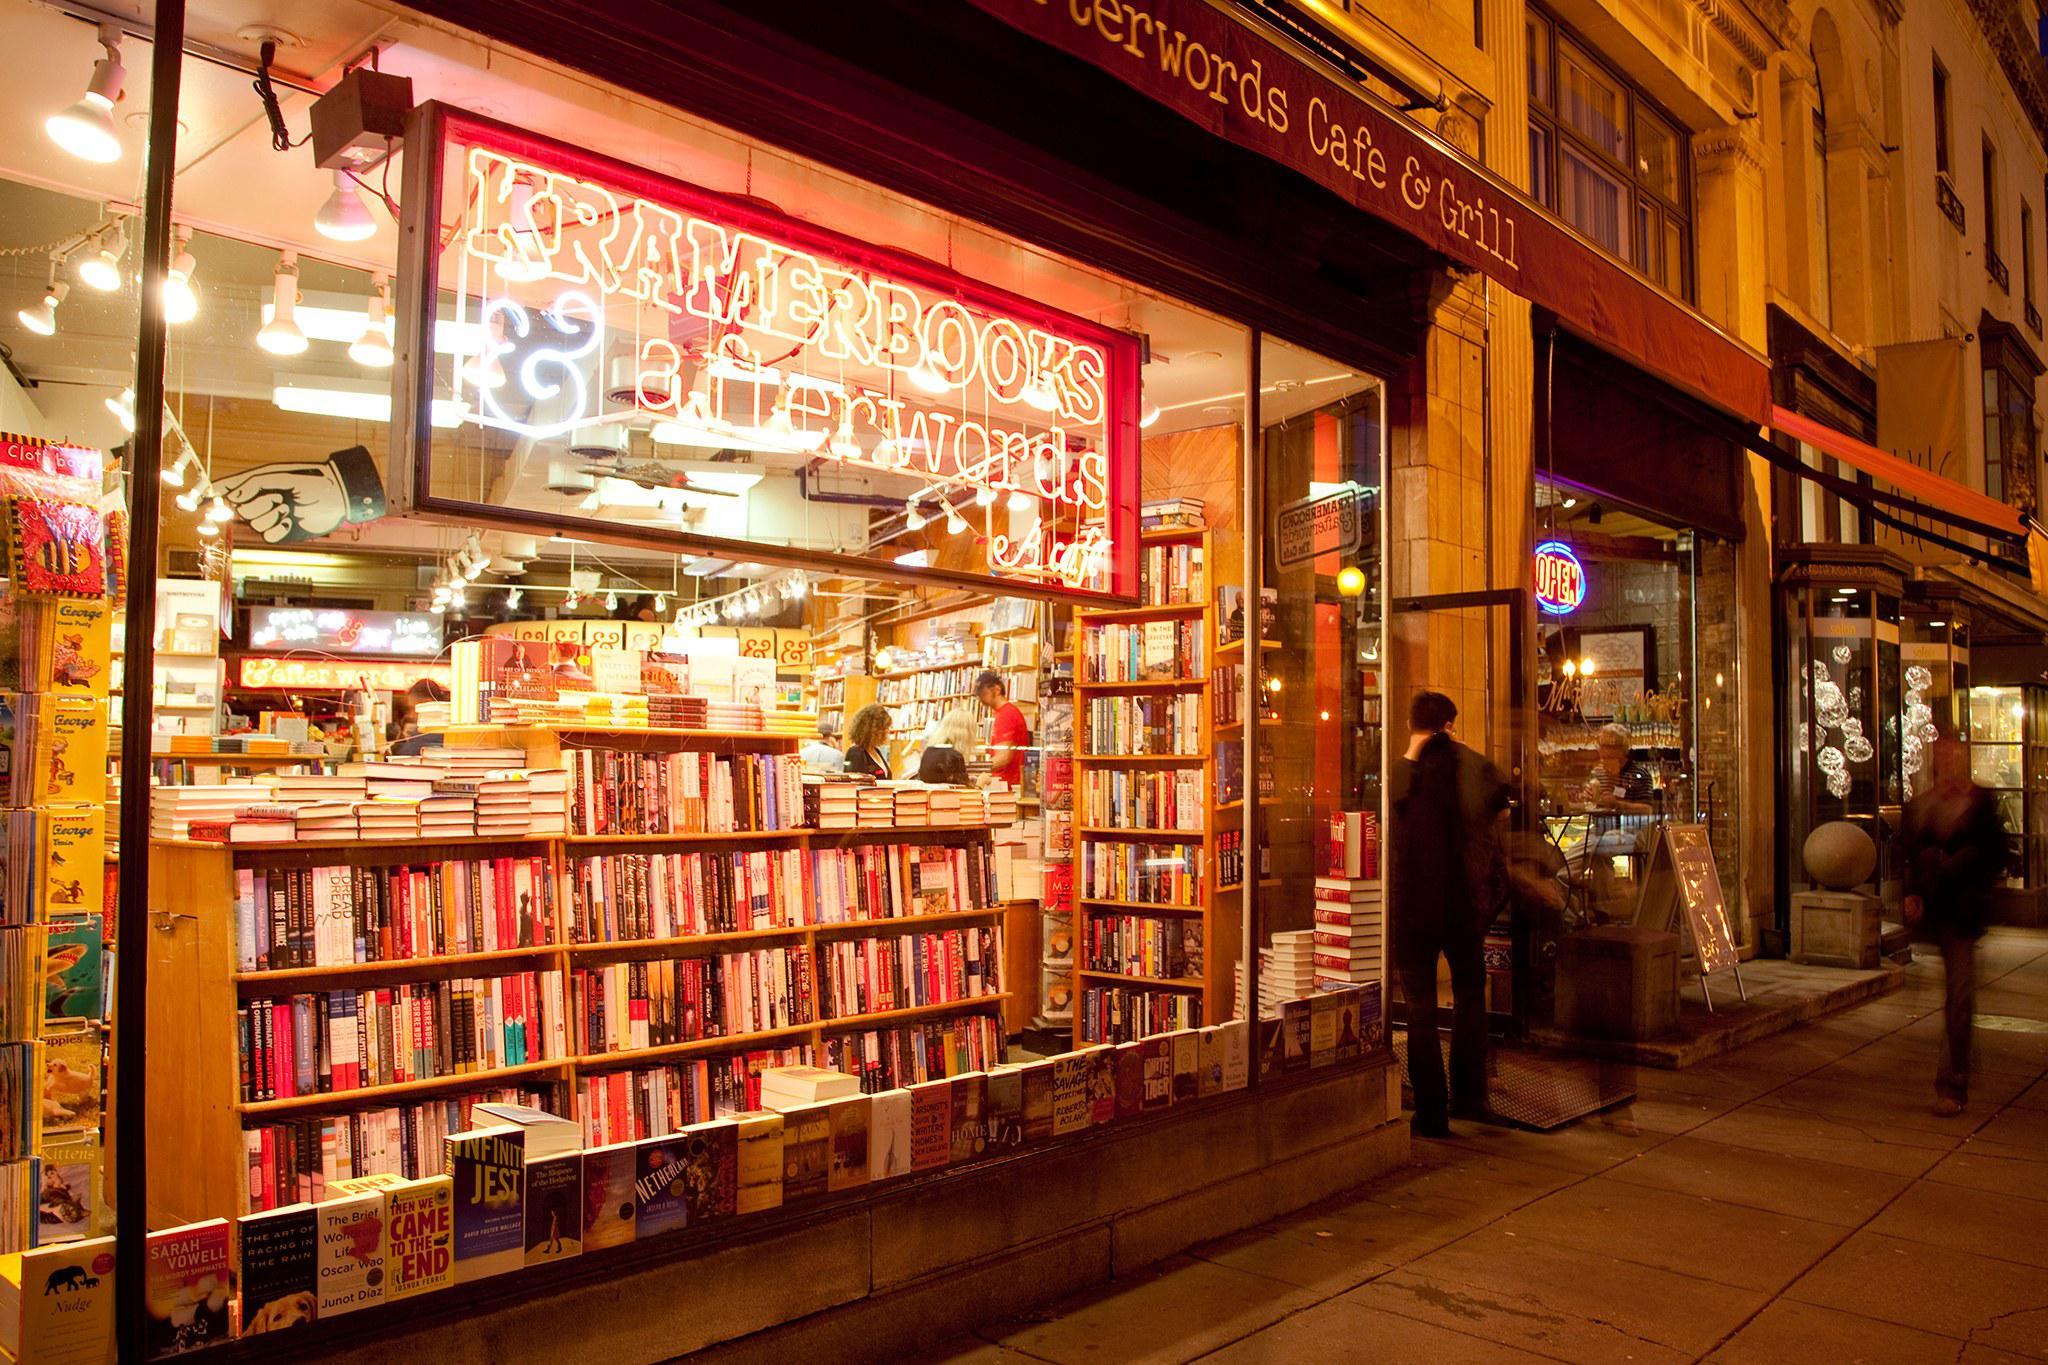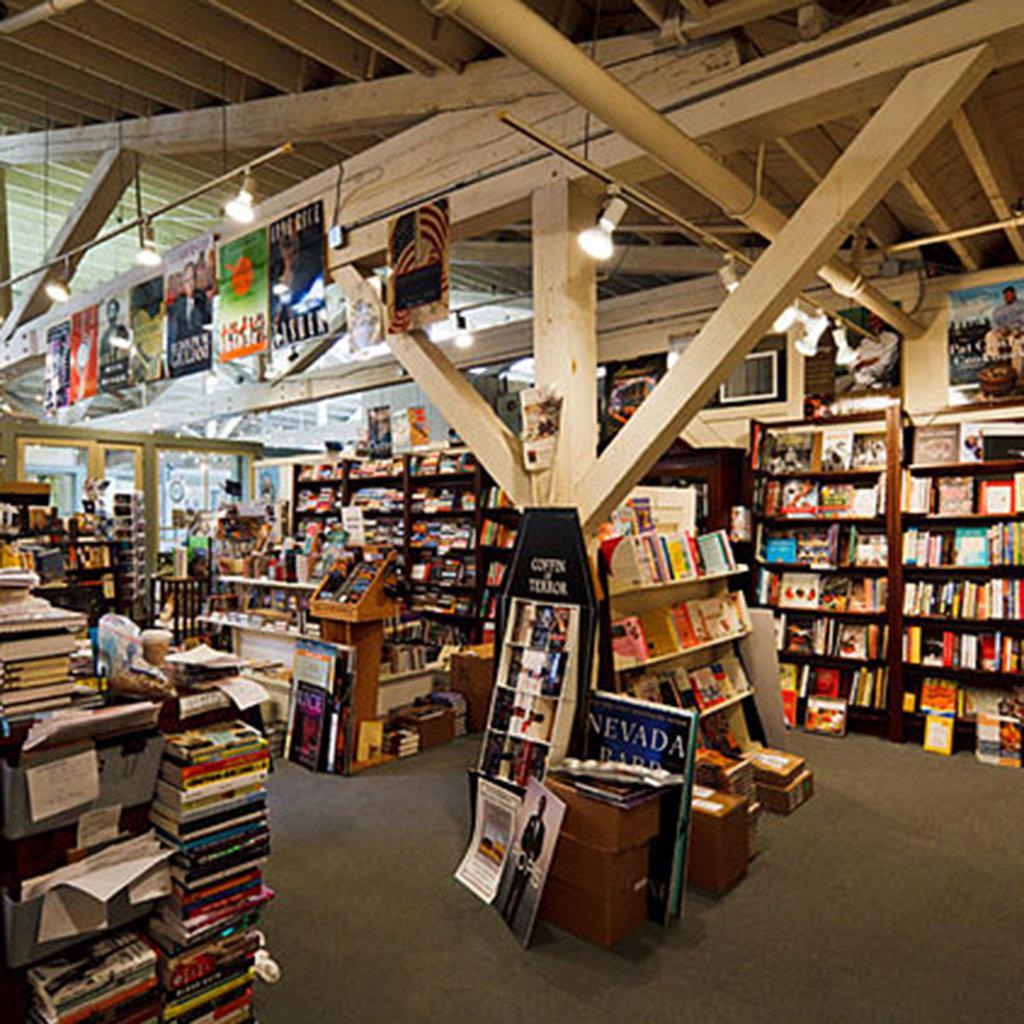The first image is the image on the left, the second image is the image on the right. Assess this claim about the two images: "No one is visible in the bookstore in the left.". Correct or not? Answer yes or no. No. The first image is the image on the left, the second image is the image on the right. Evaluate the accuracy of this statement regarding the images: "Suspended non-tube-shaped lights are visible in at least one bookstore image.". Is it true? Answer yes or no. Yes. 